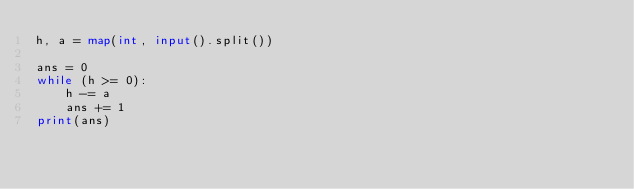Convert code to text. <code><loc_0><loc_0><loc_500><loc_500><_Python_>h, a = map(int, input().split())

ans = 0
while (h >= 0):
    h -= a
    ans += 1
print(ans)
</code> 